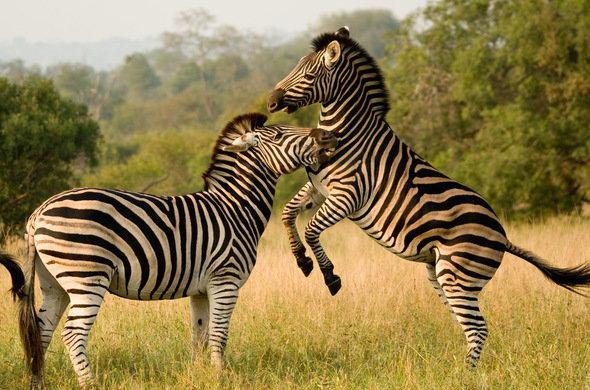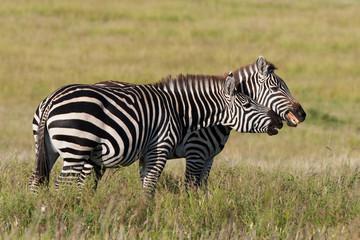The first image is the image on the left, the second image is the image on the right. Analyze the images presented: Is the assertion "Each image contains exactly two zebras, and the left image shows one zebra standing on its hind legs face-to-face and in contact with another zebra." valid? Answer yes or no. Yes. The first image is the image on the left, the second image is the image on the right. Examine the images to the left and right. Is the description "The left and right image contains the same number of zebras with at least two looking at two face to face." accurate? Answer yes or no. Yes. 